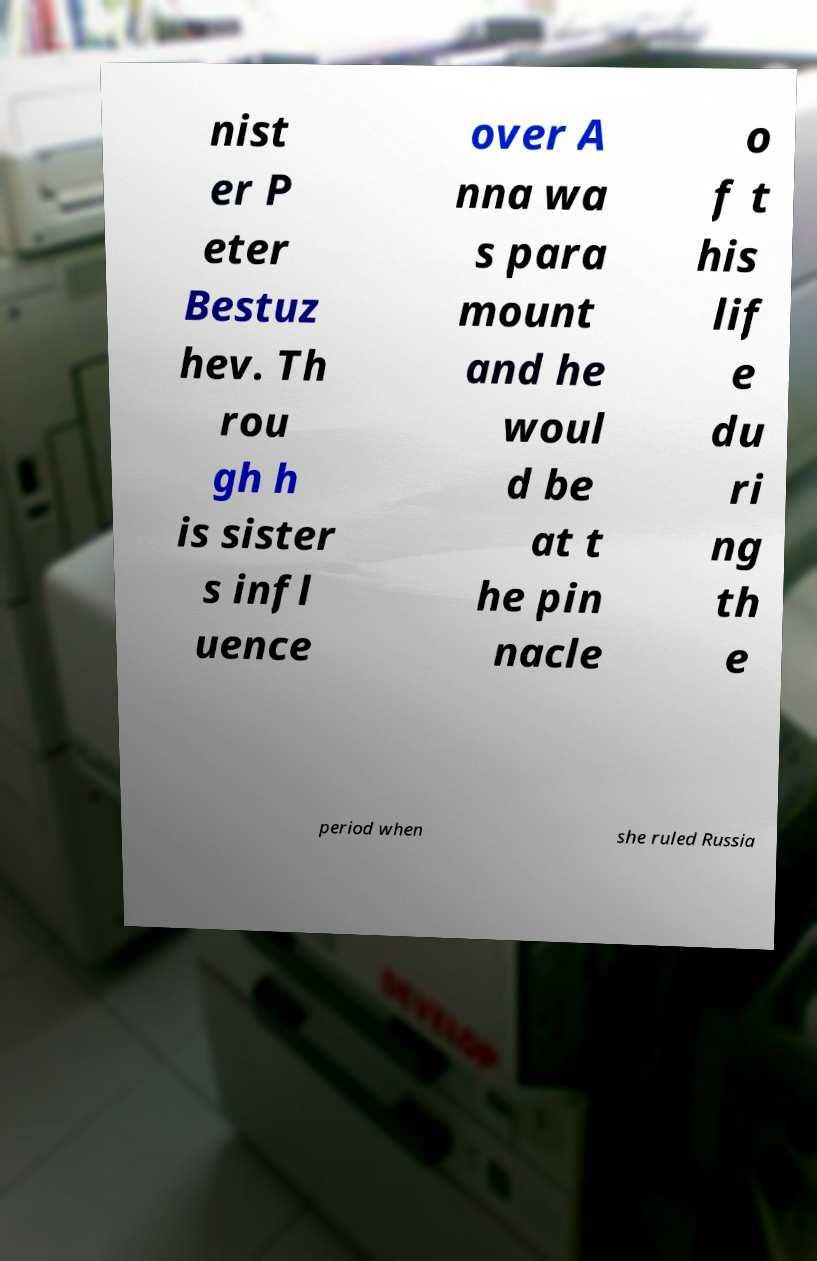Could you extract and type out the text from this image? nist er P eter Bestuz hev. Th rou gh h is sister s infl uence over A nna wa s para mount and he woul d be at t he pin nacle o f t his lif e du ri ng th e period when she ruled Russia 